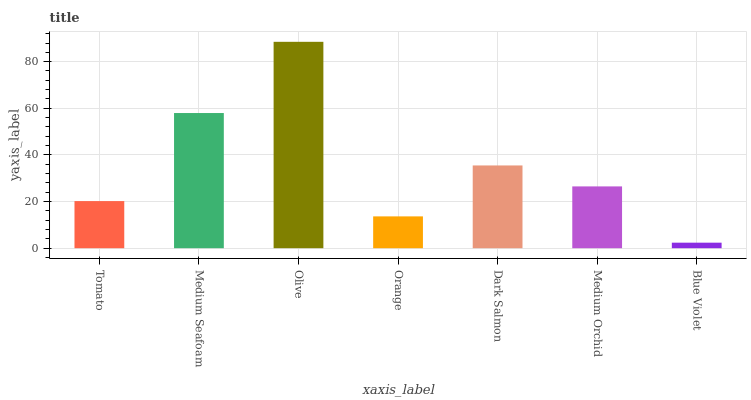Is Blue Violet the minimum?
Answer yes or no. Yes. Is Olive the maximum?
Answer yes or no. Yes. Is Medium Seafoam the minimum?
Answer yes or no. No. Is Medium Seafoam the maximum?
Answer yes or no. No. Is Medium Seafoam greater than Tomato?
Answer yes or no. Yes. Is Tomato less than Medium Seafoam?
Answer yes or no. Yes. Is Tomato greater than Medium Seafoam?
Answer yes or no. No. Is Medium Seafoam less than Tomato?
Answer yes or no. No. Is Medium Orchid the high median?
Answer yes or no. Yes. Is Medium Orchid the low median?
Answer yes or no. Yes. Is Dark Salmon the high median?
Answer yes or no. No. Is Dark Salmon the low median?
Answer yes or no. No. 